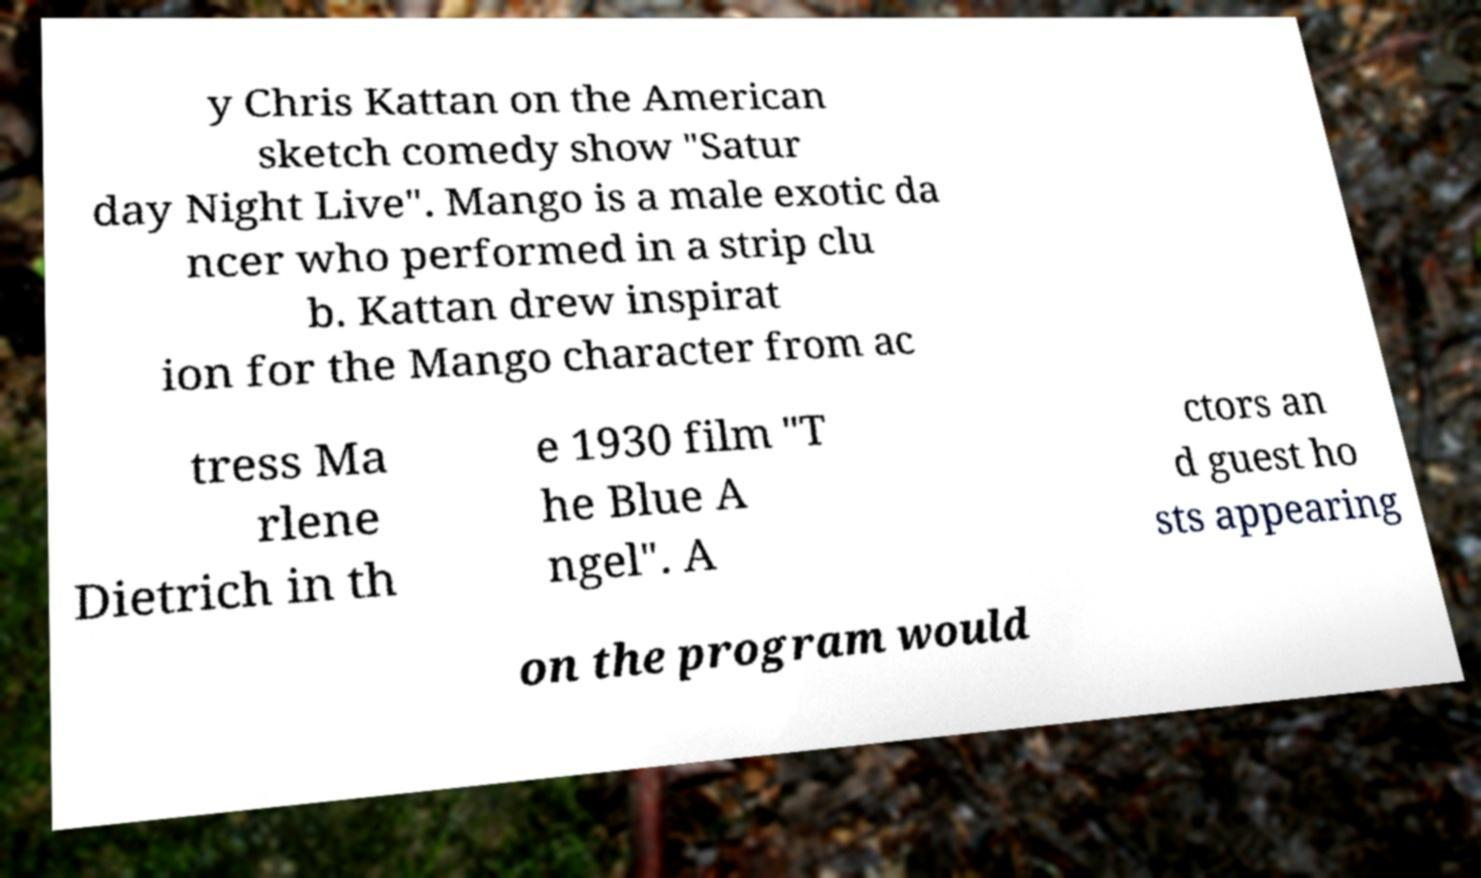Can you read and provide the text displayed in the image?This photo seems to have some interesting text. Can you extract and type it out for me? y Chris Kattan on the American sketch comedy show "Satur day Night Live". Mango is a male exotic da ncer who performed in a strip clu b. Kattan drew inspirat ion for the Mango character from ac tress Ma rlene Dietrich in th e 1930 film "T he Blue A ngel". A ctors an d guest ho sts appearing on the program would 